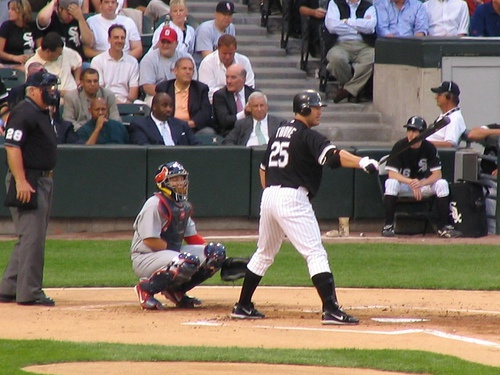Describe the objects in this image and their specific colors. I can see people in gray, black, and lavender tones, people in gray, black, lavender, and darkgray tones, people in gray, black, and brown tones, people in gray, black, darkgray, and lightgray tones, and people in gray, black, lavender, and darkgray tones in this image. 